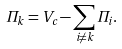<formula> <loc_0><loc_0><loc_500><loc_500>\Pi _ { k } = V _ { c } - \sum _ { i \not = k } \Pi _ { i } .</formula> 